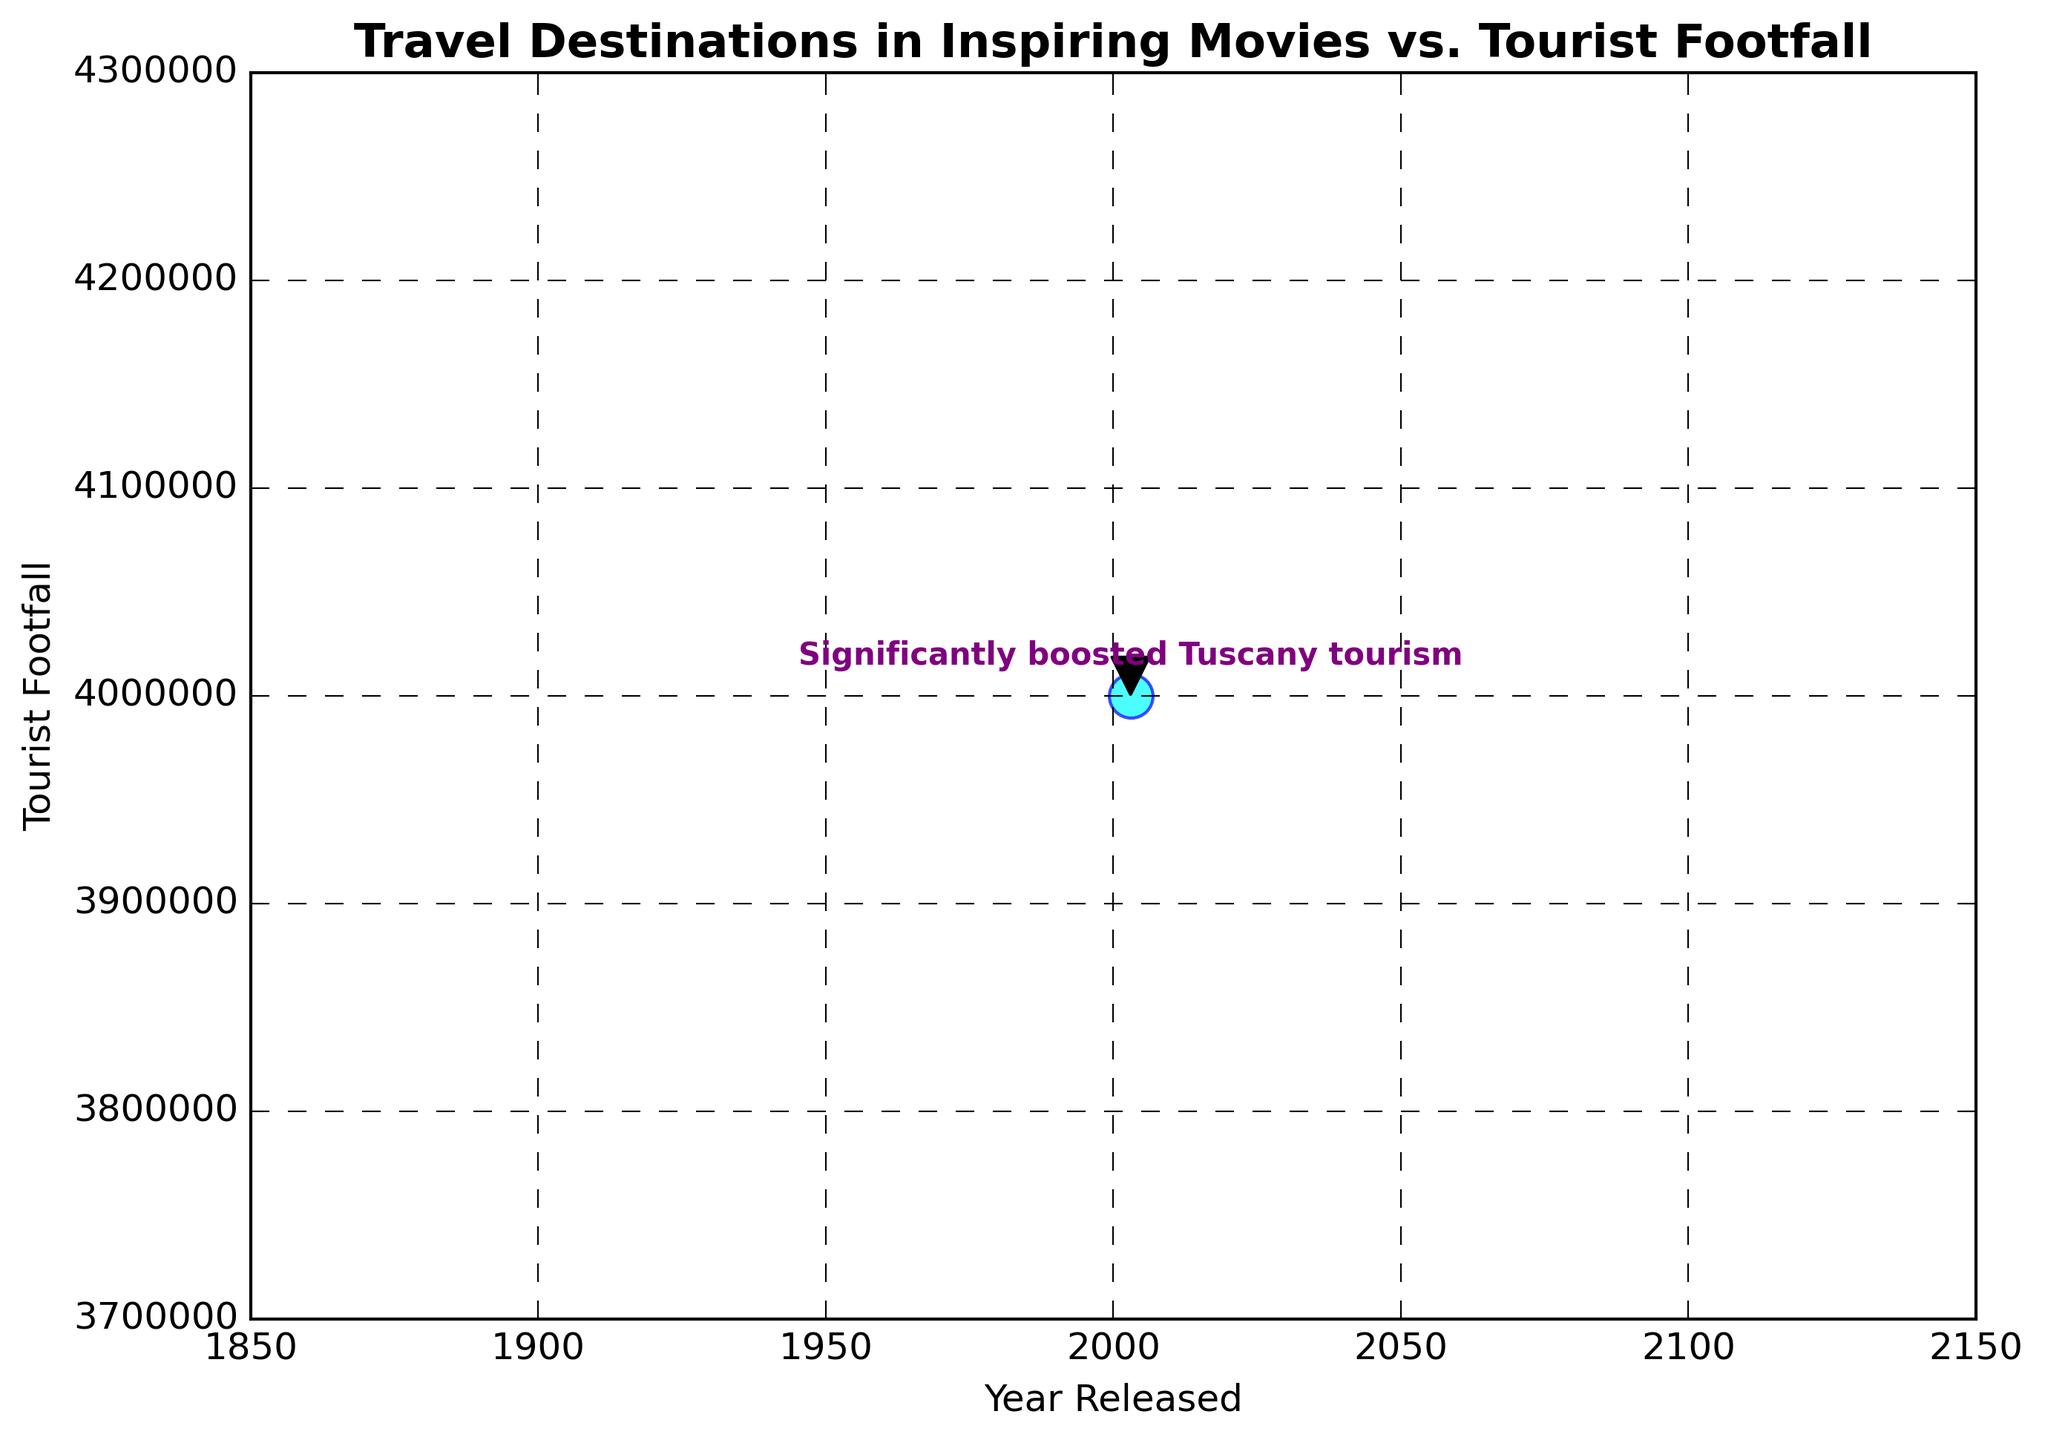What's the primary purpose of the annotation in the plot? The annotation is used to highlight specific information about the movie "Under the Tuscan Sun" and its impact on Tuscany tourism, making it easy to identify key insights related to this movie.
Answer: To highlight information about "Under the Tuscan Sun" Which movie has a notable annotation in the plot? By observing the single annotation in the plot, the movie "Under the Tuscan Sun" is the notable one highlighted.
Answer: "Under the Tuscan Sun" In what year was "Under the Tuscan Sun" released according to the plot? By referring to the x-axis of the scatter plot that represents the release years, "Under the Tuscan Sun" aligns with the year 2003.
Answer: 2003 What is the tourist footfall value for "Under the Tuscan Sun"? By looking at the y-axis value corresponding to the year 2003, the tourist footfall for "Under the Tuscan Sun" is marked at 4,000,000.
Answer: 4,000,000 What color is used for the scatter points in the plot? By visually identifying the color of the scatter points, it is clear they are colored in cyan.
Answer: Cyan How does the plot indicate the significance of "Under the Tuscan Sun" in terms of tourism? The plot highlights "Under the Tuscan Sun" with an annotation stating "Significantly boosted Tuscany tourism," emphasizing its impact clearly.
Answer: Annotation Which travel destination saw a significant tourism boost according to the annotation? The annotation specifies that Tuscany, Italy, experienced a significant tourism boost due to "Under the Tuscan Sun."
Answer: Tuscany, Italy What kind of relationship is depicted between the release year of movies and tourist footfall in the plot? The plot overall depicts individual points representing specific movies' release years and their respective tourist footfalls, with a focus on "Under the Tuscan Sun" to show the potential relation.
Answer: Release year to tourist footfall Describe the visual style used in the presented scatter plot. The plot adopts a classic visual style with cyan-colored scatter points, a grid layout, and an annotation with a purple text and black arrow, providing clarity and emphasis.
Answer: Classic style with highlighted annotation Why does the annotation for "Under the Tuscan Sun" use both text and an arrow? Visually, the combination of the bold purple text and the black arrow in the annotation draws immediate attention to the specific scatter point, ensuring viewers understand the significance of this data quickly.
Answer: To draw attention 